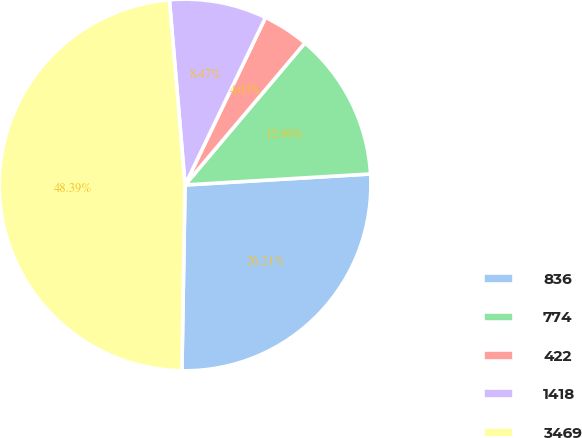Convert chart. <chart><loc_0><loc_0><loc_500><loc_500><pie_chart><fcel>836<fcel>774<fcel>422<fcel>1418<fcel>3469<nl><fcel>26.21%<fcel>12.9%<fcel>4.03%<fcel>8.47%<fcel>48.39%<nl></chart> 